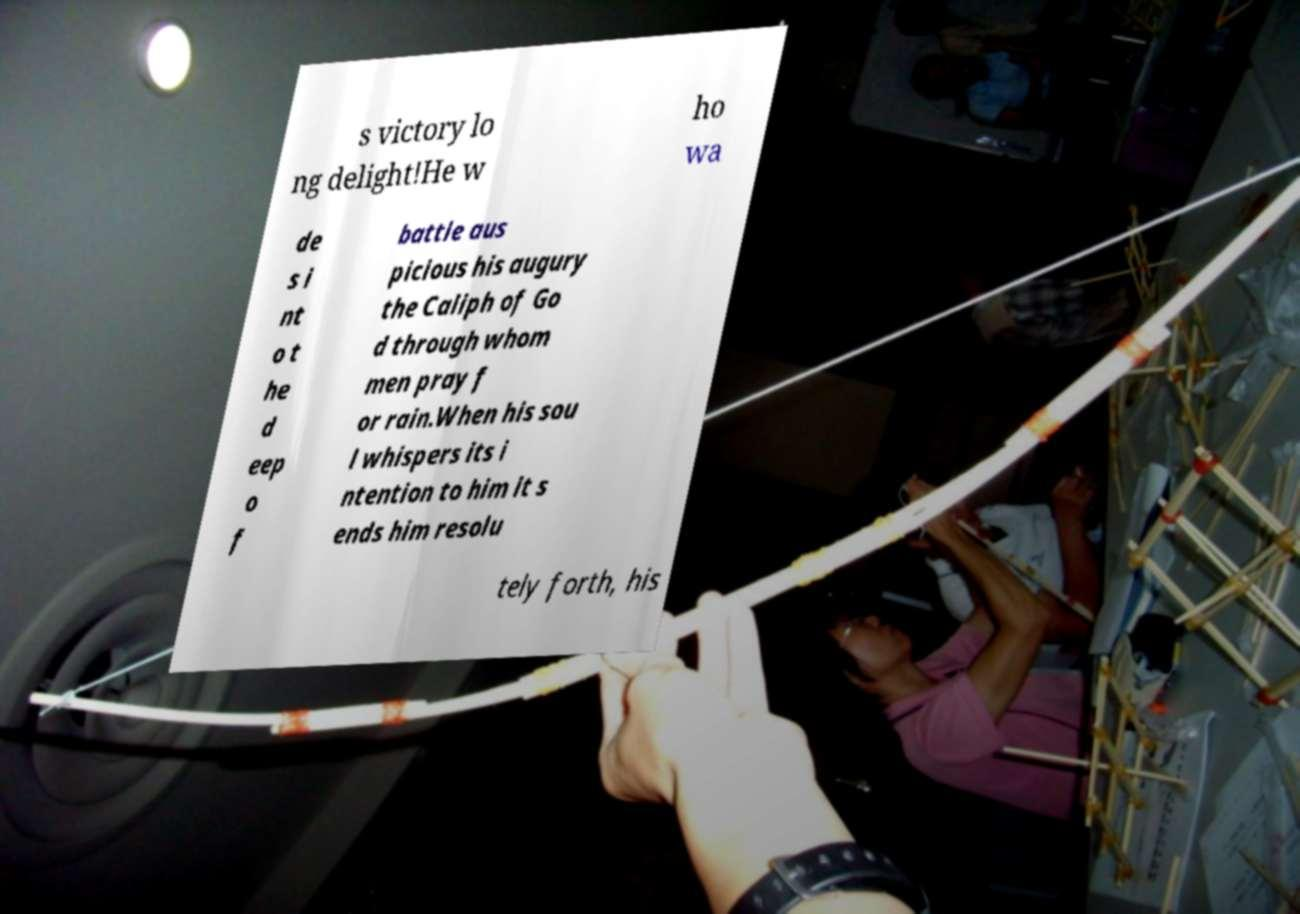What messages or text are displayed in this image? I need them in a readable, typed format. s victory lo ng delight!He w ho wa de s i nt o t he d eep o f battle aus picious his augury the Caliph of Go d through whom men pray f or rain.When his sou l whispers its i ntention to him it s ends him resolu tely forth, his 